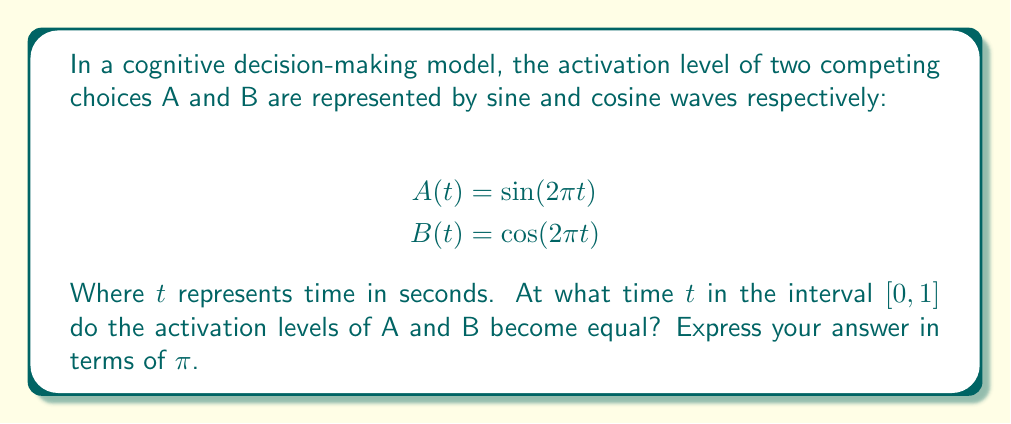Provide a solution to this math problem. Let's approach this step-by-step:

1) For the activation levels to be equal, we need:
   $$A(t) = B(t)$$

2) Substituting the given functions:
   $$\sin(2\pi t) = \cos(2\pi t)$$

3) This equation is satisfied when:
   $$2\pi t = \frac{\pi}{4}$$ 
   (Because $\sin x = \cos x$ when $x = \frac{\pi}{4}$ in the first quadrant)

4) Solving for $t$:
   $$t = \frac{1}{8}$$

5) To express this in terms of $\pi$ as requested:
   $$t = \frac{\pi}{8\pi} = \frac{1}{8}\pi$$

6) We need to verify if this solution falls within the given interval $[0, 1]$:
   $$\frac{1}{8}\pi \approx 0.3927 < 1$$

   So, the solution is indeed within the required interval.
Answer: $\frac{1}{8}\pi$ 